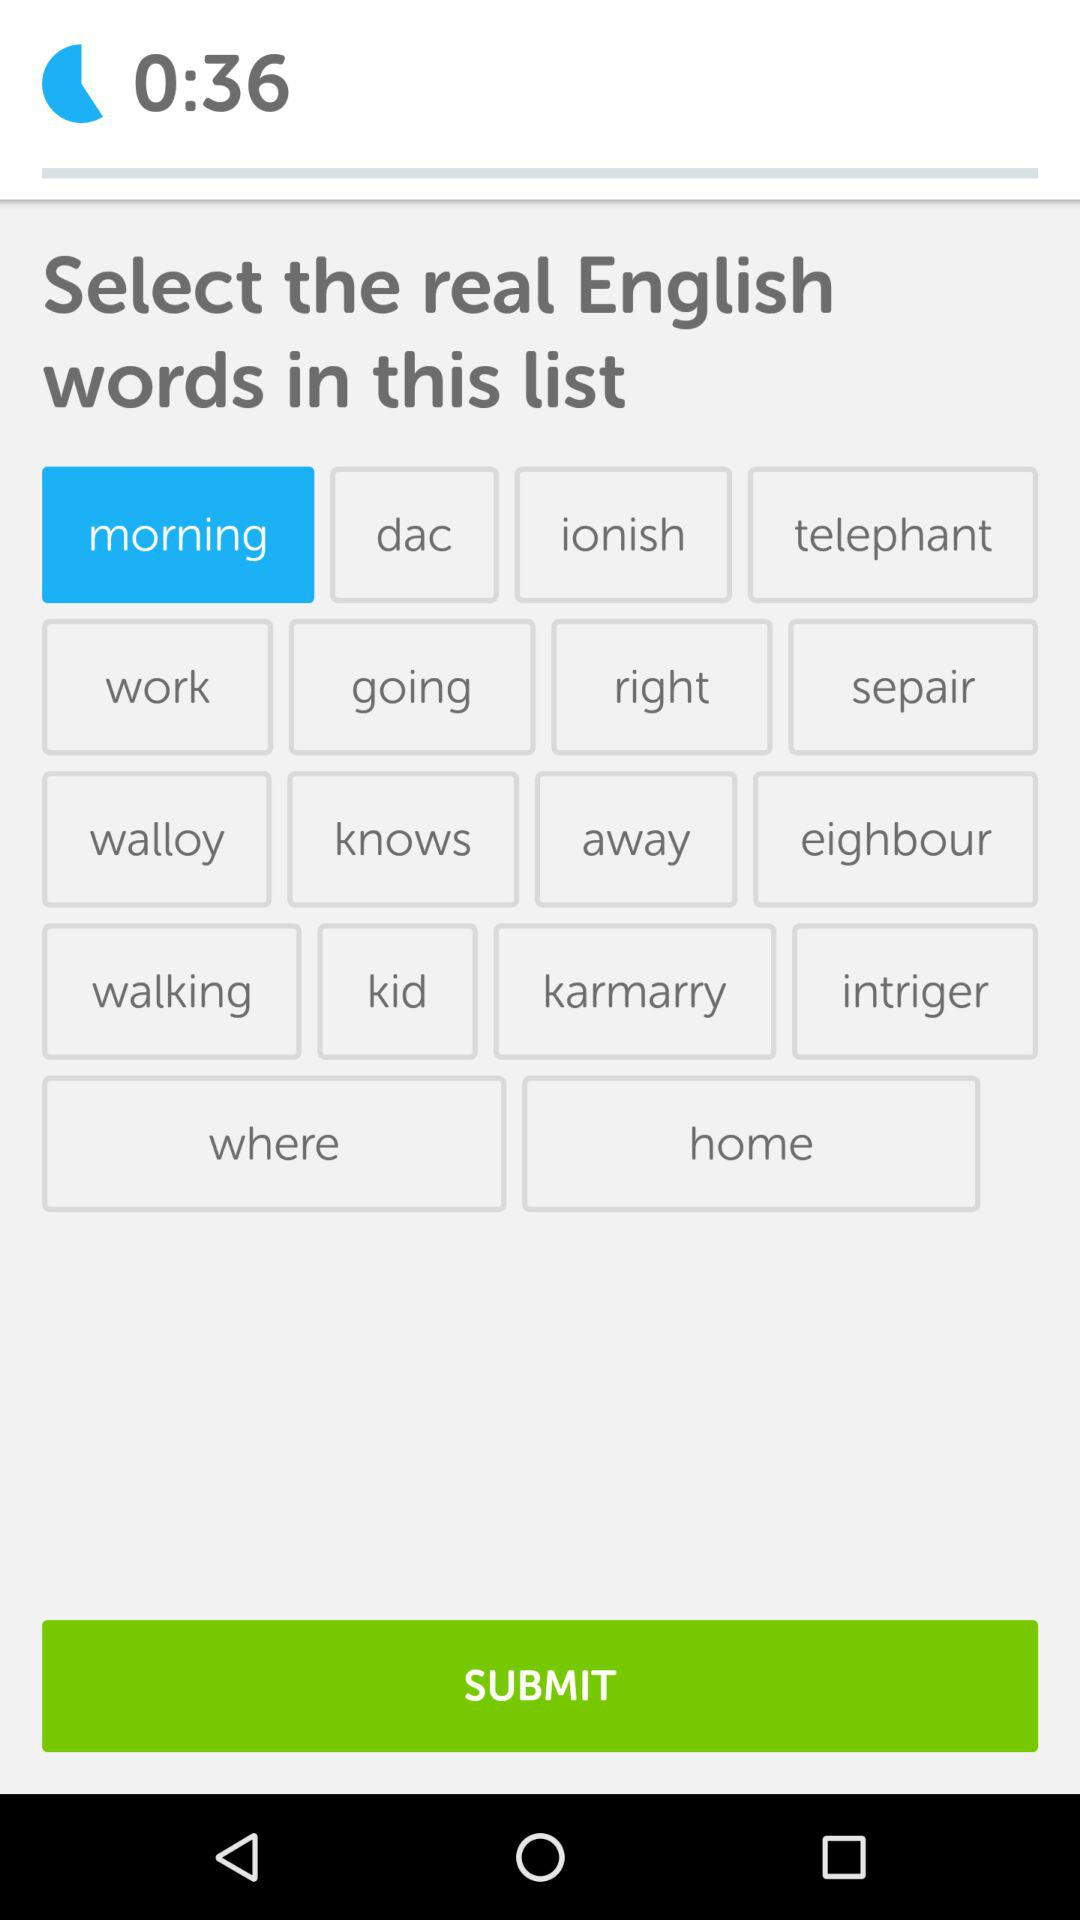How many total questions are there?
When the provided information is insufficient, respond with <no answer>. <no answer> 